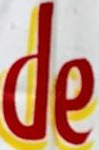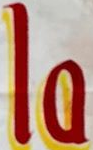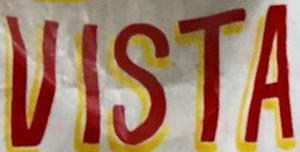Identify the words shown in these images in order, separated by a semicolon. de; la; VISTA 